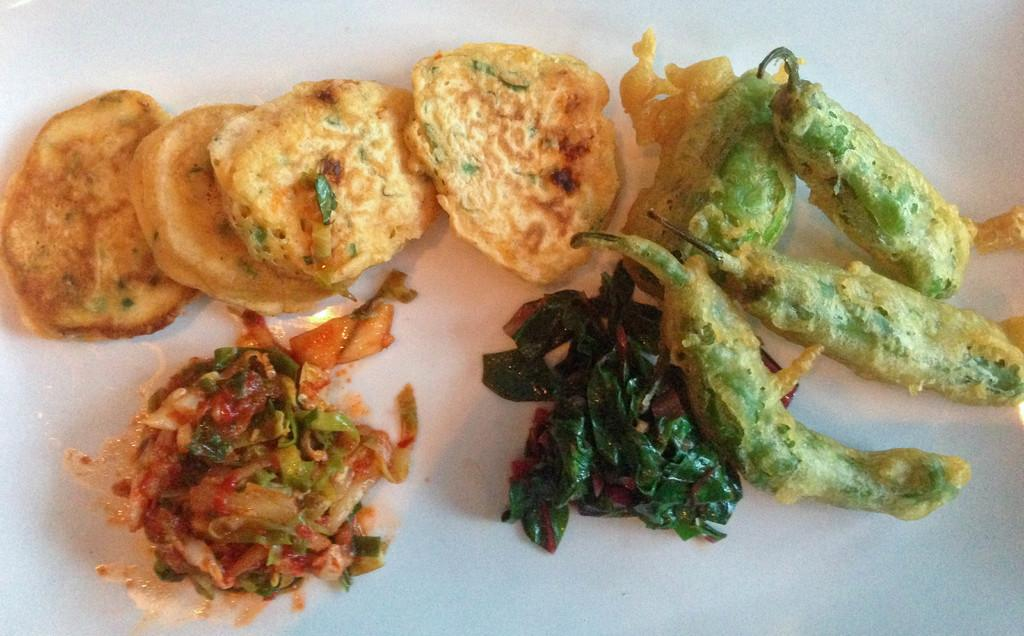What is the main subject of the image? The main subject of the image is food items. Where are the food items located in the image? The food items are in the center of the image. How are the food items arranged in the image? The food items are on a plate. What type of hook can be seen holding the food items in the image? There is no hook present in the image; the food items are on a plate. Is there a flame visible near the food items in the image? No, there is no flame visible near the food items in the image. 